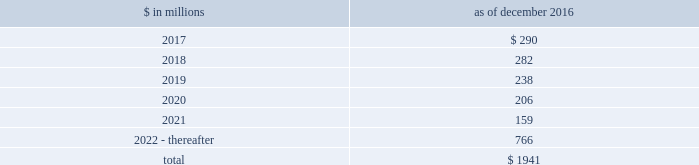The goldman sachs group , inc .
And subsidiaries notes to consolidated financial statements commercial lending .
The firm 2019s commercial lending commitments are extended to investment-grade and non- investment-grade corporate borrowers .
Commitments to investment-grade corporate borrowers are principally used for operating liquidity and general corporate purposes .
The firm also extends lending commitments in connection with contingent acquisition financing and other types of corporate lending as well as commercial real estate financing .
Commitments that are extended for contingent acquisition financing are often intended to be short-term in nature , as borrowers often seek to replace them with other funding sources .
Sumitomo mitsui financial group , inc .
( smfg ) provides the firm with credit loss protection on certain approved loan commitments ( primarily investment-grade commercial lending commitments ) .
The notional amount of such loan commitments was $ 26.88 billion and $ 27.03 billion as of december 2016 and december 2015 , respectively .
The credit loss protection on loan commitments provided by smfg is generally limited to 95% ( 95 % ) of the first loss the firm realizes on such commitments , up to a maximum of approximately $ 950 million .
In addition , subject to the satisfaction of certain conditions , upon the firm 2019s request , smfg will provide protection for 70% ( 70 % ) of additional losses on such commitments , up to a maximum of $ 1.13 billion , of which $ 768 million of protection had been provided as of both december 2016 and december 2015 .
The firm also uses other financial instruments to mitigate credit risks related to certain commitments not covered by smfg .
These instruments primarily include credit default swaps that reference the same or similar underlying instrument or entity , or credit default swaps that reference a market index .
Warehouse financing .
The firm provides financing to clients who warehouse financial assets .
These arrangements are secured by the warehoused assets , primarily consisting of consumer and corporate loans .
Contingent and forward starting resale and securities borrowing agreements/forward starting repurchase and secured lending agreements the firm enters into resale and securities borrowing agreements and repurchase and secured lending agreements that settle at a future date , generally within three business days .
The firm also enters into commitments to provide contingent financing to its clients and counterparties through resale agreements .
The firm 2019s funding of these commitments depends on the satisfaction of all contractual conditions to the resale agreement and these commitments can expire unused .
Letters of credit the firm has commitments under letters of credit issued by various banks which the firm provides to counterparties in lieu of securities or cash to satisfy various collateral and margin deposit requirements .
Investment commitments the firm 2019s investment commitments include commitments to invest in private equity , real estate and other assets directly and through funds that the firm raises and manages .
Investment commitments include $ 2.10 billion and $ 2.86 billion as of december 2016 and december 2015 , respectively , related to commitments to invest in funds managed by the firm .
If these commitments are called , they would be funded at market value on the date of investment .
Leases the firm has contractual obligations under long-term noncancelable lease agreements for office space expiring on various dates through 2069 .
Certain agreements are subject to periodic escalation provisions for increases in real estate taxes and other charges .
The table below presents future minimum rental payments , net of minimum sublease rentals .
$ in millions december 2016 .
Rent charged to operating expense was $ 244 million for 2016 , $ 249 million for 2015 and $ 309 million for 2014 .
Operating leases include office space held in excess of current requirements .
Rent expense relating to space held for growth is included in 201coccupancy . 201d the firm records a liability , based on the fair value of the remaining lease rentals reduced by any potential or existing sublease rentals , for leases where the firm has ceased using the space and management has concluded that the firm will not derive any future economic benefits .
Costs to terminate a lease before the end of its term are recognized and measured at fair value on termination .
During 2016 , the firm incurred exit costs of approximately $ 68 million related to excess office space .
Goldman sachs 2016 form 10-k 169 .
What percentage of future minimum rental payments are due in 2017? 
Computations: (290 / 1941)
Answer: 0.14941. The goldman sachs group , inc .
And subsidiaries notes to consolidated financial statements commercial lending .
The firm 2019s commercial lending commitments are extended to investment-grade and non- investment-grade corporate borrowers .
Commitments to investment-grade corporate borrowers are principally used for operating liquidity and general corporate purposes .
The firm also extends lending commitments in connection with contingent acquisition financing and other types of corporate lending as well as commercial real estate financing .
Commitments that are extended for contingent acquisition financing are often intended to be short-term in nature , as borrowers often seek to replace them with other funding sources .
Sumitomo mitsui financial group , inc .
( smfg ) provides the firm with credit loss protection on certain approved loan commitments ( primarily investment-grade commercial lending commitments ) .
The notional amount of such loan commitments was $ 26.88 billion and $ 27.03 billion as of december 2016 and december 2015 , respectively .
The credit loss protection on loan commitments provided by smfg is generally limited to 95% ( 95 % ) of the first loss the firm realizes on such commitments , up to a maximum of approximately $ 950 million .
In addition , subject to the satisfaction of certain conditions , upon the firm 2019s request , smfg will provide protection for 70% ( 70 % ) of additional losses on such commitments , up to a maximum of $ 1.13 billion , of which $ 768 million of protection had been provided as of both december 2016 and december 2015 .
The firm also uses other financial instruments to mitigate credit risks related to certain commitments not covered by smfg .
These instruments primarily include credit default swaps that reference the same or similar underlying instrument or entity , or credit default swaps that reference a market index .
Warehouse financing .
The firm provides financing to clients who warehouse financial assets .
These arrangements are secured by the warehoused assets , primarily consisting of consumer and corporate loans .
Contingent and forward starting resale and securities borrowing agreements/forward starting repurchase and secured lending agreements the firm enters into resale and securities borrowing agreements and repurchase and secured lending agreements that settle at a future date , generally within three business days .
The firm also enters into commitments to provide contingent financing to its clients and counterparties through resale agreements .
The firm 2019s funding of these commitments depends on the satisfaction of all contractual conditions to the resale agreement and these commitments can expire unused .
Letters of credit the firm has commitments under letters of credit issued by various banks which the firm provides to counterparties in lieu of securities or cash to satisfy various collateral and margin deposit requirements .
Investment commitments the firm 2019s investment commitments include commitments to invest in private equity , real estate and other assets directly and through funds that the firm raises and manages .
Investment commitments include $ 2.10 billion and $ 2.86 billion as of december 2016 and december 2015 , respectively , related to commitments to invest in funds managed by the firm .
If these commitments are called , they would be funded at market value on the date of investment .
Leases the firm has contractual obligations under long-term noncancelable lease agreements for office space expiring on various dates through 2069 .
Certain agreements are subject to periodic escalation provisions for increases in real estate taxes and other charges .
The table below presents future minimum rental payments , net of minimum sublease rentals .
$ in millions december 2016 .
Rent charged to operating expense was $ 244 million for 2016 , $ 249 million for 2015 and $ 309 million for 2014 .
Operating leases include office space held in excess of current requirements .
Rent expense relating to space held for growth is included in 201coccupancy . 201d the firm records a liability , based on the fair value of the remaining lease rentals reduced by any potential or existing sublease rentals , for leases where the firm has ceased using the space and management has concluded that the firm will not derive any future economic benefits .
Costs to terminate a lease before the end of its term are recognized and measured at fair value on termination .
During 2016 , the firm incurred exit costs of approximately $ 68 million related to excess office space .
Goldman sachs 2016 form 10-k 169 .
What were total investment commitments in billions for 2016 and 2015 related to commitments to invest in funds managed by the firm? 
Computations: (2.10 + 2.86)
Answer: 4.96. The goldman sachs group , inc .
And subsidiaries notes to consolidated financial statements commercial lending .
The firm 2019s commercial lending commitments are extended to investment-grade and non- investment-grade corporate borrowers .
Commitments to investment-grade corporate borrowers are principally used for operating liquidity and general corporate purposes .
The firm also extends lending commitments in connection with contingent acquisition financing and other types of corporate lending as well as commercial real estate financing .
Commitments that are extended for contingent acquisition financing are often intended to be short-term in nature , as borrowers often seek to replace them with other funding sources .
Sumitomo mitsui financial group , inc .
( smfg ) provides the firm with credit loss protection on certain approved loan commitments ( primarily investment-grade commercial lending commitments ) .
The notional amount of such loan commitments was $ 26.88 billion and $ 27.03 billion as of december 2016 and december 2015 , respectively .
The credit loss protection on loan commitments provided by smfg is generally limited to 95% ( 95 % ) of the first loss the firm realizes on such commitments , up to a maximum of approximately $ 950 million .
In addition , subject to the satisfaction of certain conditions , upon the firm 2019s request , smfg will provide protection for 70% ( 70 % ) of additional losses on such commitments , up to a maximum of $ 1.13 billion , of which $ 768 million of protection had been provided as of both december 2016 and december 2015 .
The firm also uses other financial instruments to mitigate credit risks related to certain commitments not covered by smfg .
These instruments primarily include credit default swaps that reference the same or similar underlying instrument or entity , or credit default swaps that reference a market index .
Warehouse financing .
The firm provides financing to clients who warehouse financial assets .
These arrangements are secured by the warehoused assets , primarily consisting of consumer and corporate loans .
Contingent and forward starting resale and securities borrowing agreements/forward starting repurchase and secured lending agreements the firm enters into resale and securities borrowing agreements and repurchase and secured lending agreements that settle at a future date , generally within three business days .
The firm also enters into commitments to provide contingent financing to its clients and counterparties through resale agreements .
The firm 2019s funding of these commitments depends on the satisfaction of all contractual conditions to the resale agreement and these commitments can expire unused .
Letters of credit the firm has commitments under letters of credit issued by various banks which the firm provides to counterparties in lieu of securities or cash to satisfy various collateral and margin deposit requirements .
Investment commitments the firm 2019s investment commitments include commitments to invest in private equity , real estate and other assets directly and through funds that the firm raises and manages .
Investment commitments include $ 2.10 billion and $ 2.86 billion as of december 2016 and december 2015 , respectively , related to commitments to invest in funds managed by the firm .
If these commitments are called , they would be funded at market value on the date of investment .
Leases the firm has contractual obligations under long-term noncancelable lease agreements for office space expiring on various dates through 2069 .
Certain agreements are subject to periodic escalation provisions for increases in real estate taxes and other charges .
The table below presents future minimum rental payments , net of minimum sublease rentals .
$ in millions december 2016 .
Rent charged to operating expense was $ 244 million for 2016 , $ 249 million for 2015 and $ 309 million for 2014 .
Operating leases include office space held in excess of current requirements .
Rent expense relating to space held for growth is included in 201coccupancy . 201d the firm records a liability , based on the fair value of the remaining lease rentals reduced by any potential or existing sublease rentals , for leases where the firm has ceased using the space and management has concluded that the firm will not derive any future economic benefits .
Costs to terminate a lease before the end of its term are recognized and measured at fair value on termination .
During 2016 , the firm incurred exit costs of approximately $ 68 million related to excess office space .
Goldman sachs 2016 form 10-k 169 .
What was total rent charged to operating expense in millions for 2016 , 2015 and 2014? 
Computations: ((244 + 249) + 309)
Answer: 802.0. 